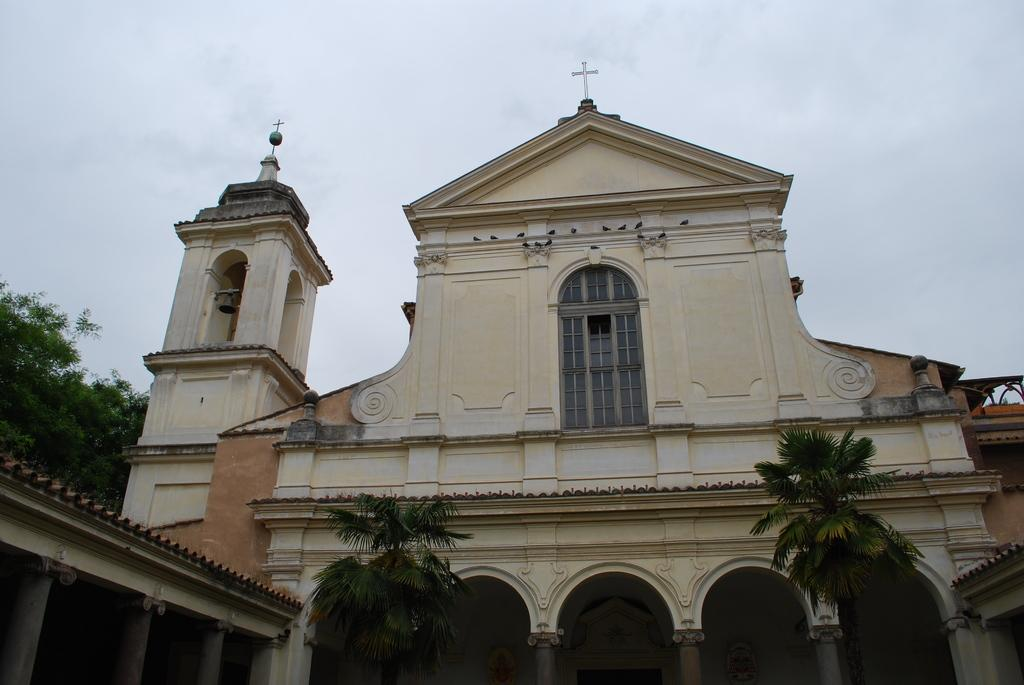What can be seen in the foreground area of the image? There are trees and a church in the foreground area of the image. What else is present in the foreground area of the image? There is also a roof visible. What can be seen in the background of the image? There are trees and the sky visible in the background of the image. What type of office can be seen in the image? There is no office present in the image; it features trees, a church, and a roof in the foreground, with trees and the sky in the background. How many clouds are visible in the image? There is no mention of clouds in the provided facts, so it cannot be determined how many clouds are visible in the image. 